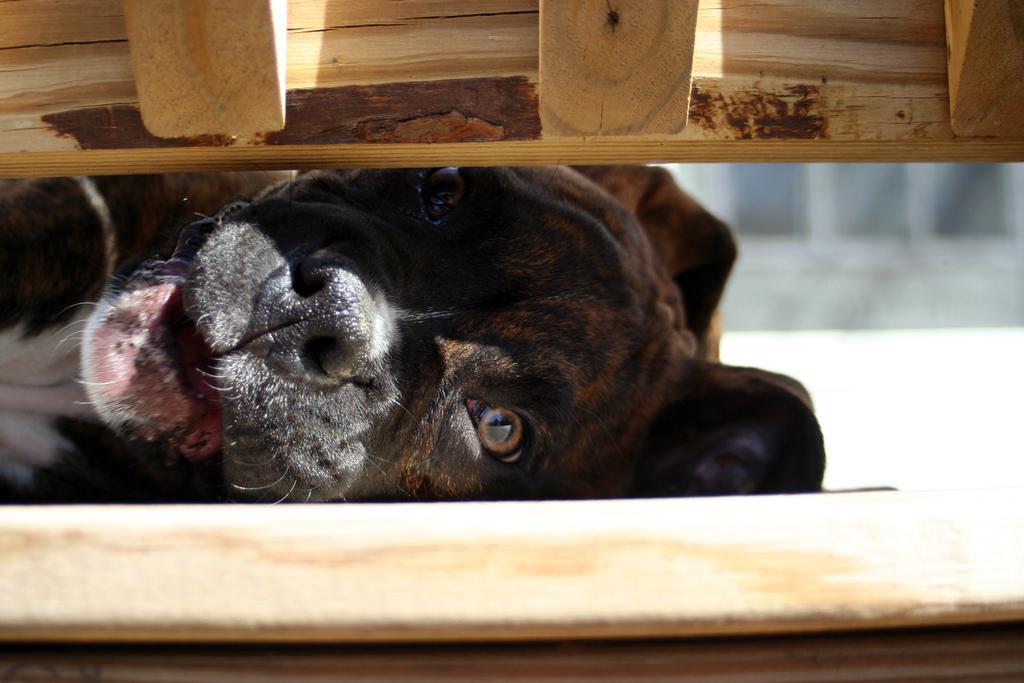Describe this image in one or two sentences. In this image we can see a dog between the wooden fence. 